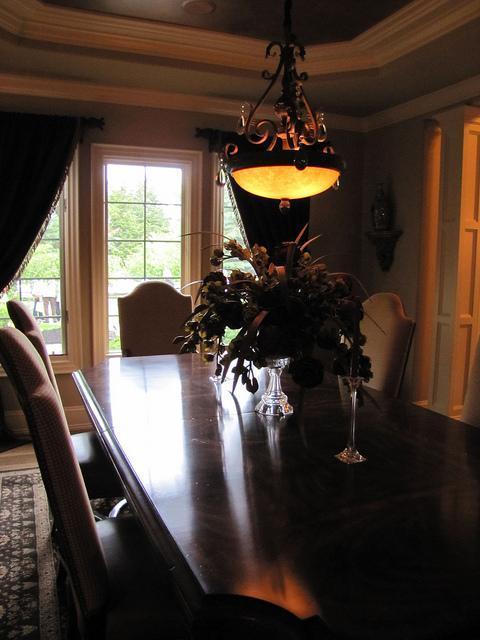How many dining tables are in the picture?
Give a very brief answer. 1. How many chairs are in the photo?
Give a very brief answer. 3. 